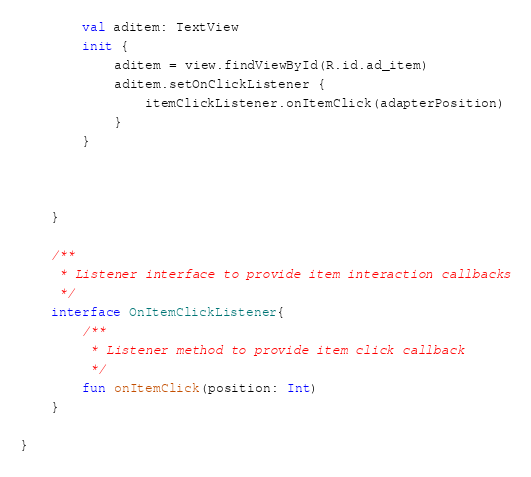<code> <loc_0><loc_0><loc_500><loc_500><_Kotlin_>        val aditem: TextView
        init {
            aditem = view.findViewById(R.id.ad_item)
            aditem.setOnClickListener {
                itemClickListener.onItemClick(adapterPosition)
            }
        }



    }

    /**
     * Listener interface to provide item interaction callbacks
     */
    interface OnItemClickListener{
        /**
         * Listener method to provide item click callback
         */
        fun onItemClick(position: Int)
    }

}</code> 